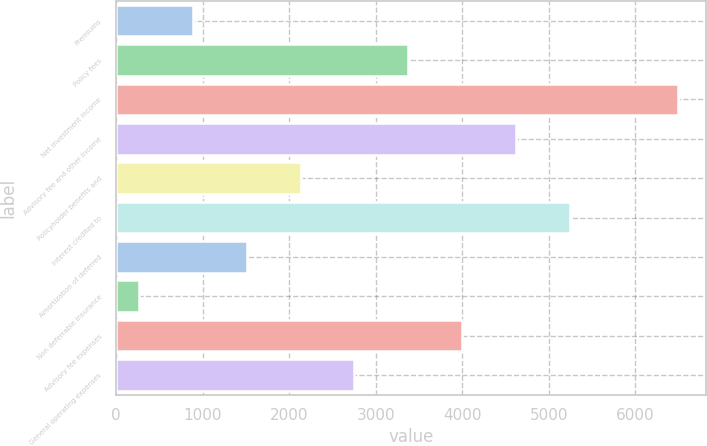Convert chart to OTSL. <chart><loc_0><loc_0><loc_500><loc_500><bar_chart><fcel>Premiums<fcel>Policy fees<fcel>Net investment income<fcel>Advisory fee and other income<fcel>Policyholder benefits and<fcel>Interest credited to<fcel>Amortization of deferred<fcel>Non deferrable insurance<fcel>Advisory fee expenses<fcel>General operating expenses<nl><fcel>887.4<fcel>3377<fcel>6489<fcel>4621.8<fcel>2132.2<fcel>5244.2<fcel>1509.8<fcel>265<fcel>3999.4<fcel>2754.6<nl></chart> 